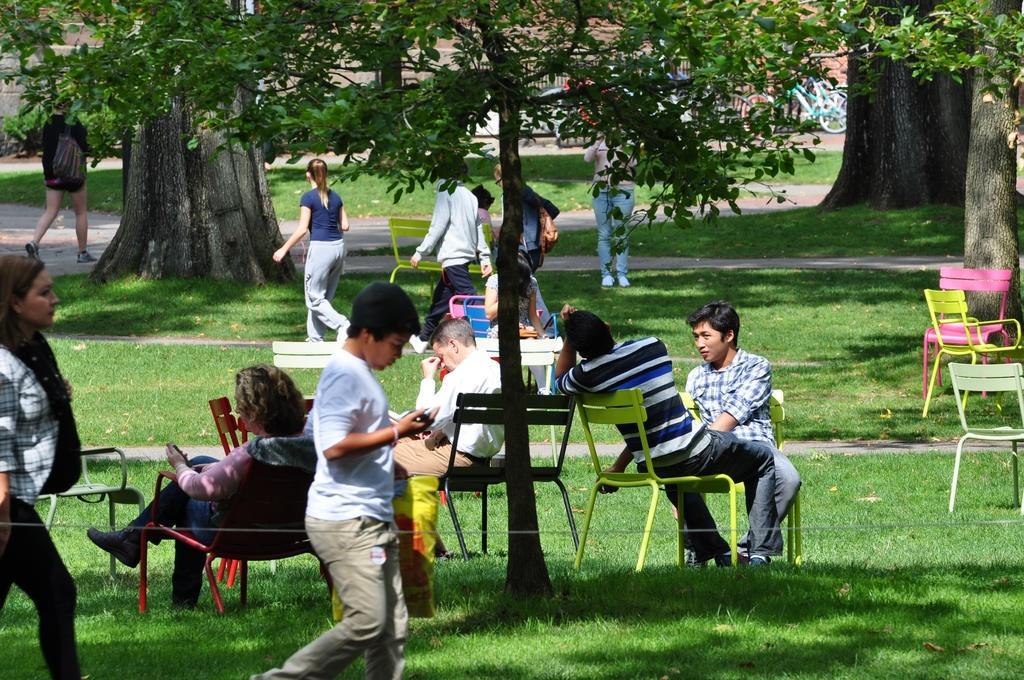How would you summarize this image in a sentence or two? In this image we can see some people in a ground, a few of them are sitting, a few of them are walking and a person is standing, a boy holding some objects and there are trees, chairs and bicycles. 